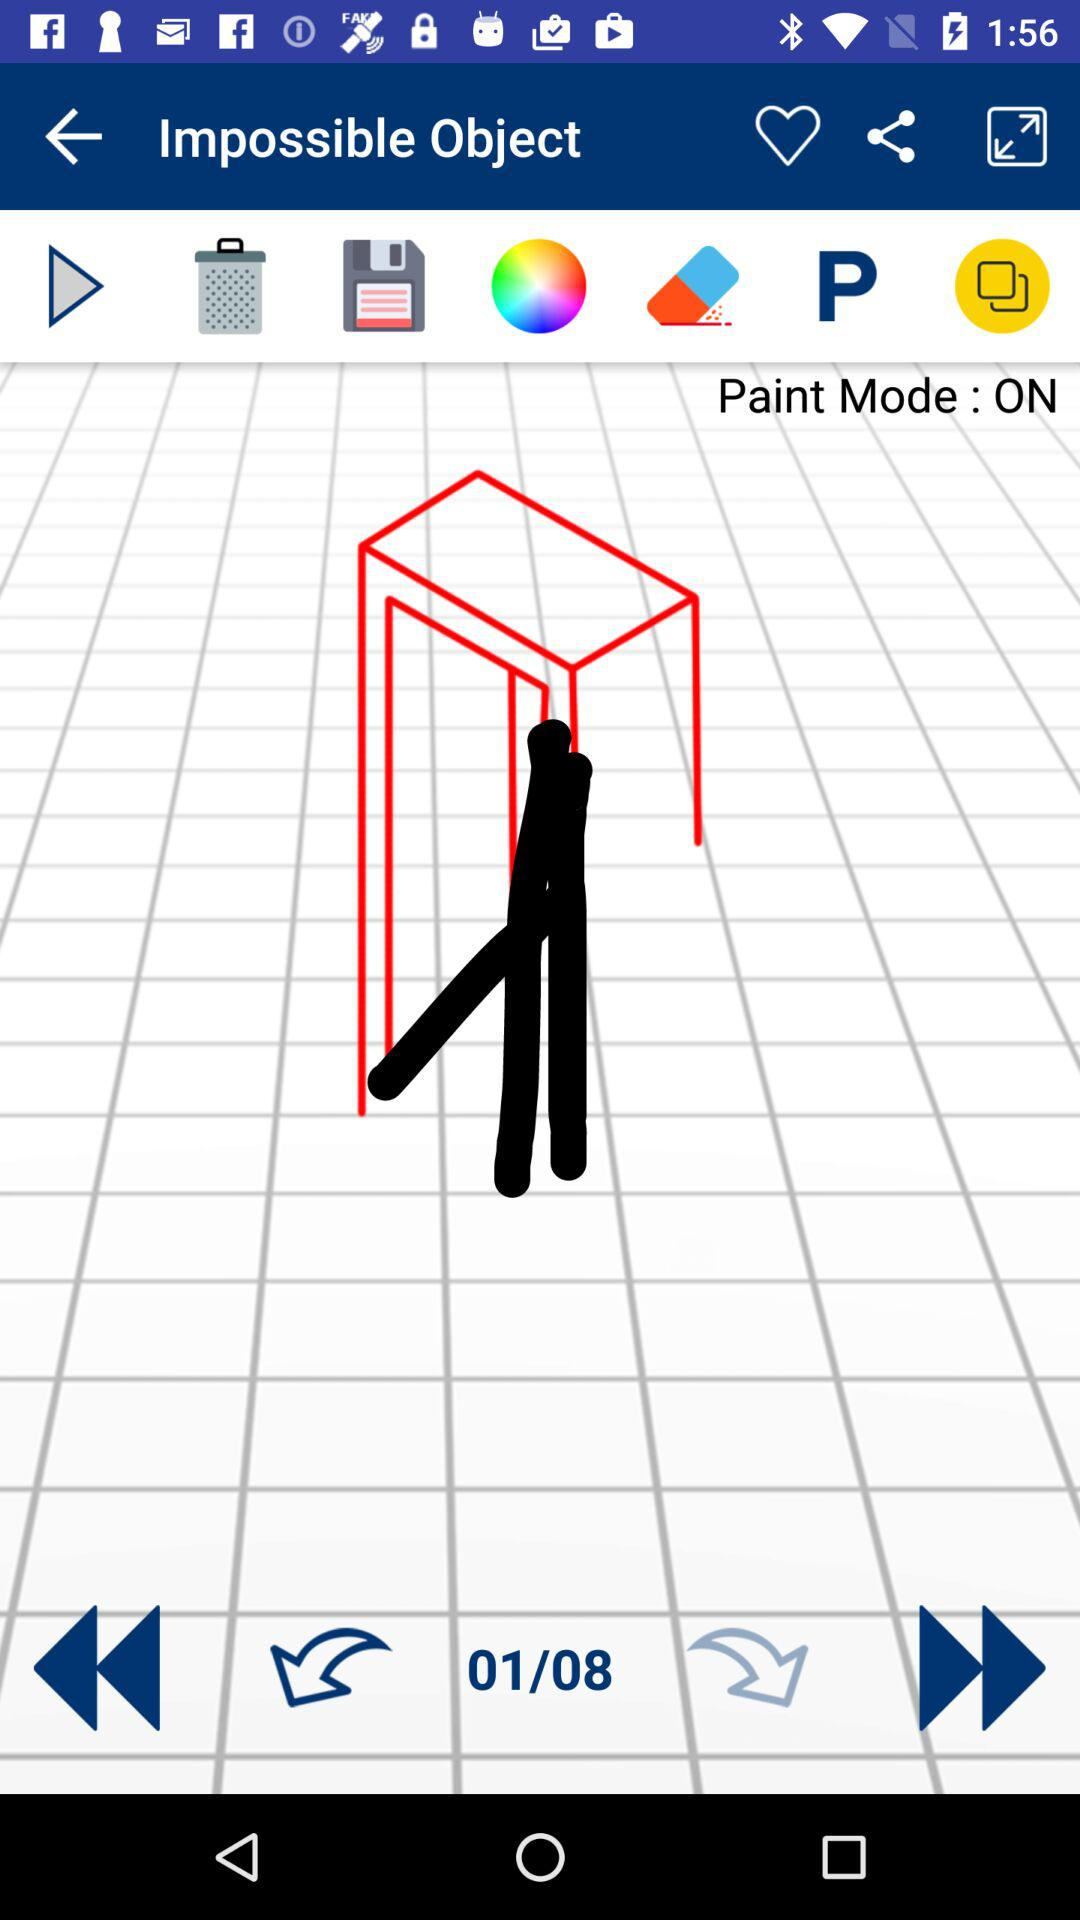What is the name of the application?
When the provided information is insufficient, respond with <no answer>. <no answer> 